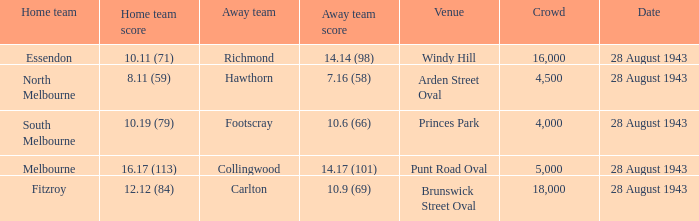Where was the match held with a visiting team score of 1 Punt Road Oval. 